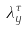Convert formula to latex. <formula><loc_0><loc_0><loc_500><loc_500>\lambda _ { y } ^ { \tau }</formula> 